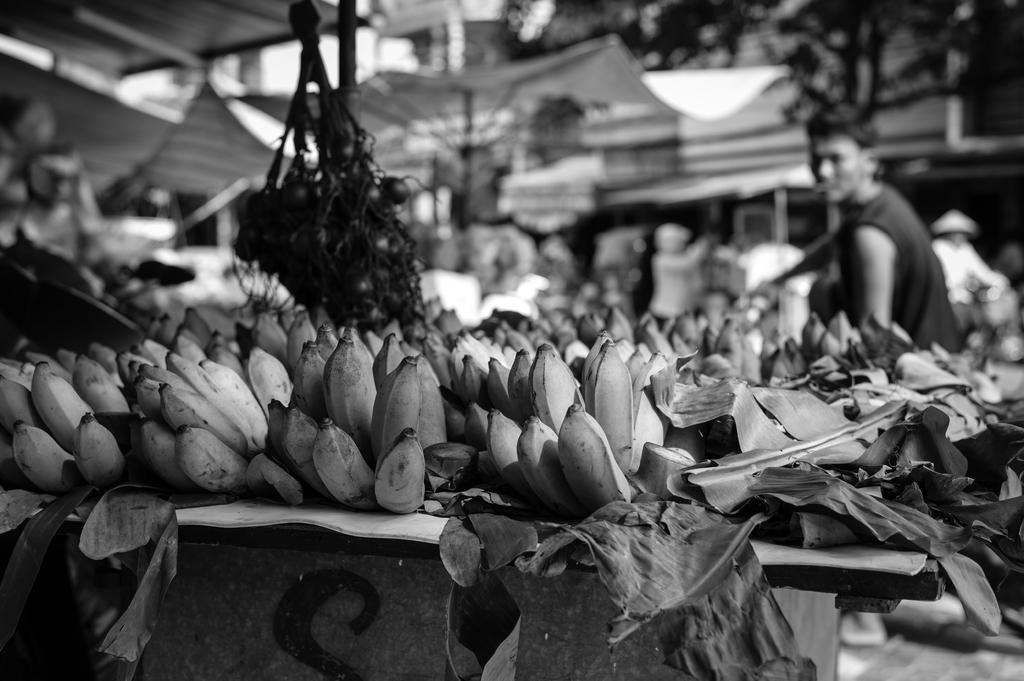What is the main object in the center of the image? There is a table in the center of the image. What is on top of the table? Leaves and bananas are on the table. What can be seen in the background of the image? Buildings, tents, banners, and trees are visible in the background of the image. Are there any people present in the image? Yes, there are people in the background of the image. What type of ray is swimming in the image? There is no ray present in the image; it features a table with leaves and bananas, as well as a background with buildings, tents, banners, and trees. What ornament is hanging from the banner in the image? There is no ornament mentioned or visible in the image; only banners are present in the background. 